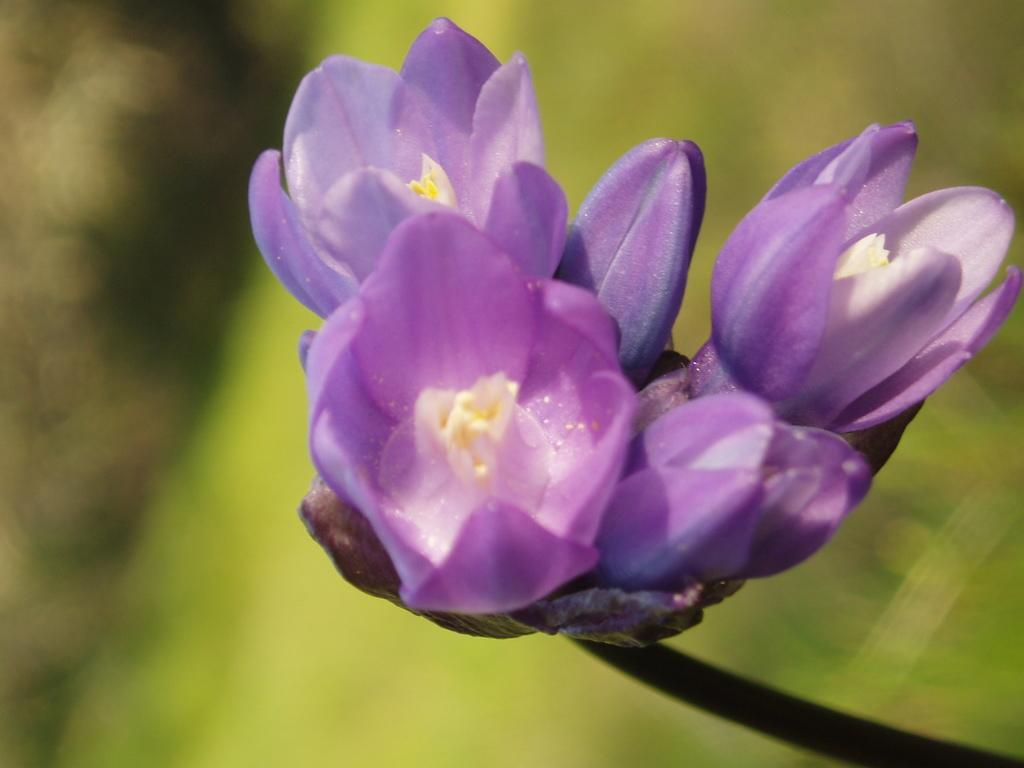What type of plants can be seen in the picture? There are flowers in the picture. Can you describe the background of the image? The background of the image is blurred. What type of basin is visible in the picture? There is no basin present in the picture; it only features flowers and a blurred background. How many forks can be seen in the picture? There are no forks present in the picture. 